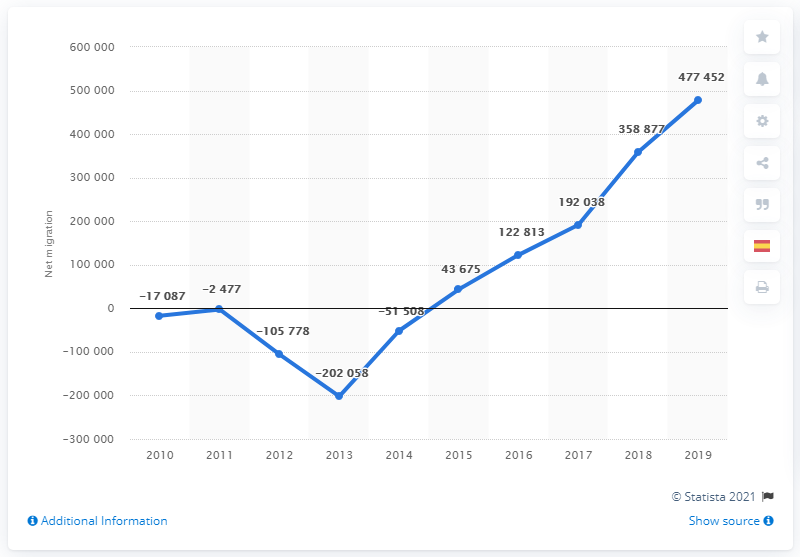Mention a couple of crucial points in this snapshot. Spain's net migration rate in 2018 was approximately 358,877 people. 